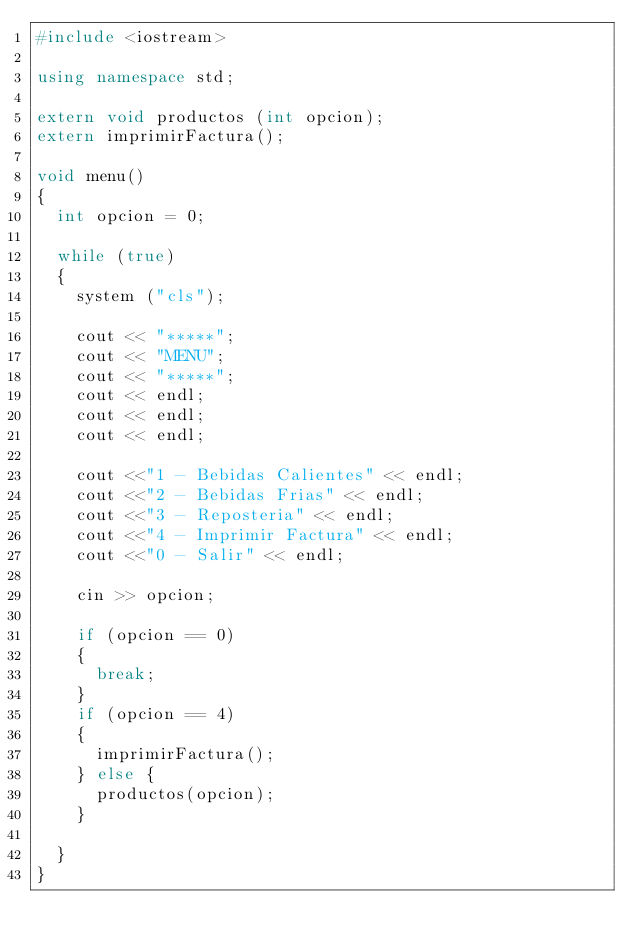<code> <loc_0><loc_0><loc_500><loc_500><_C++_>#include <iostream>

using namespace std;

extern void productos (int opcion);
extern imprimirFactura();

void menu()
{
	int opcion = 0;
	
	while (true)
	{
		system ("cls");
		
		cout << "*****";
		cout << "MENU";
		cout << "*****";
		cout << endl;
		cout << endl;
		cout << endl;
		
		cout <<"1 - Bebidas Calientes" << endl;
		cout <<"2 - Bebidas Frias" << endl;
		cout <<"3 - Reposteria" << endl;
		cout <<"4 - Imprimir Factura" << endl;
		cout <<"0 - Salir" << endl;
		
		cin >> opcion;
	    
		if (opcion == 0)
		{
			break;
		}	
		if (opcion == 4)
		{
			imprimirFactura();
		} else {
			productos(opcion);
		}	
			
	}
}

</code> 